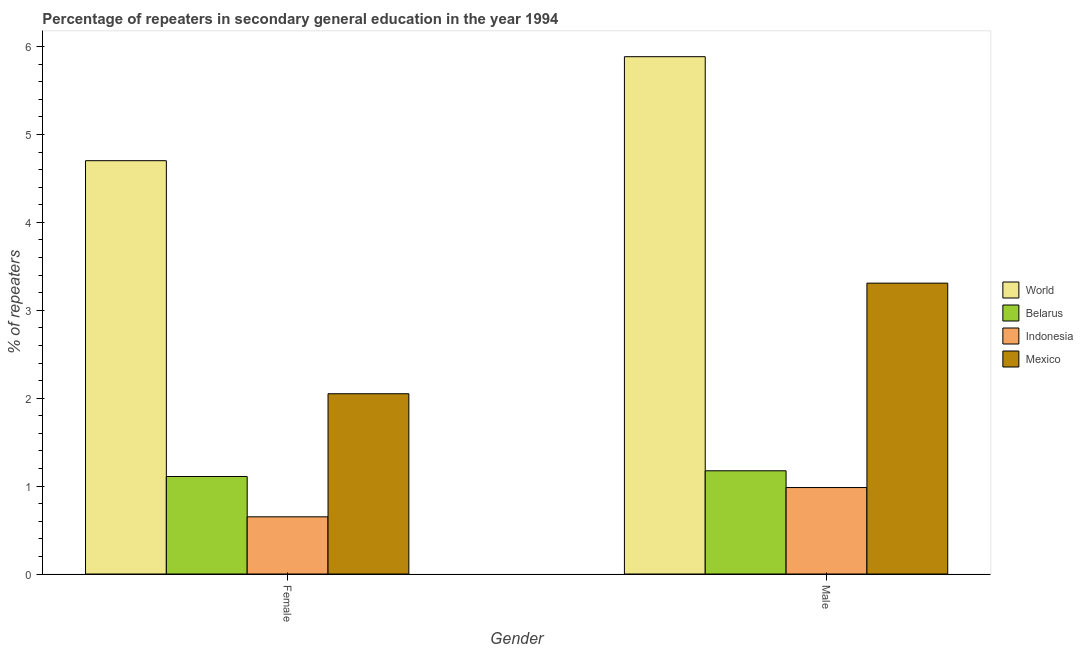How many groups of bars are there?
Give a very brief answer. 2. Are the number of bars on each tick of the X-axis equal?
Your answer should be very brief. Yes. How many bars are there on the 1st tick from the left?
Offer a terse response. 4. How many bars are there on the 1st tick from the right?
Offer a very short reply. 4. What is the percentage of female repeaters in World?
Your answer should be very brief. 4.7. Across all countries, what is the maximum percentage of male repeaters?
Provide a short and direct response. 5.89. Across all countries, what is the minimum percentage of female repeaters?
Provide a short and direct response. 0.65. What is the total percentage of male repeaters in the graph?
Provide a short and direct response. 11.35. What is the difference between the percentage of male repeaters in Mexico and that in Belarus?
Ensure brevity in your answer.  2.13. What is the difference between the percentage of male repeaters in Mexico and the percentage of female repeaters in Indonesia?
Your answer should be compact. 2.66. What is the average percentage of female repeaters per country?
Ensure brevity in your answer.  2.13. What is the difference between the percentage of female repeaters and percentage of male repeaters in World?
Your answer should be compact. -1.18. What is the ratio of the percentage of male repeaters in Belarus to that in Mexico?
Keep it short and to the point. 0.35. Is the percentage of female repeaters in Indonesia less than that in Belarus?
Your answer should be compact. Yes. What does the 2nd bar from the left in Male represents?
Give a very brief answer. Belarus. Are all the bars in the graph horizontal?
Make the answer very short. No. How many countries are there in the graph?
Your answer should be very brief. 4. Are the values on the major ticks of Y-axis written in scientific E-notation?
Give a very brief answer. No. Does the graph contain grids?
Your response must be concise. No. Where does the legend appear in the graph?
Your answer should be very brief. Center right. How many legend labels are there?
Make the answer very short. 4. What is the title of the graph?
Make the answer very short. Percentage of repeaters in secondary general education in the year 1994. Does "Netherlands" appear as one of the legend labels in the graph?
Make the answer very short. No. What is the label or title of the X-axis?
Offer a terse response. Gender. What is the label or title of the Y-axis?
Your answer should be compact. % of repeaters. What is the % of repeaters in World in Female?
Provide a short and direct response. 4.7. What is the % of repeaters in Belarus in Female?
Keep it short and to the point. 1.11. What is the % of repeaters in Indonesia in Female?
Provide a short and direct response. 0.65. What is the % of repeaters in Mexico in Female?
Your answer should be compact. 2.05. What is the % of repeaters in World in Male?
Your answer should be compact. 5.89. What is the % of repeaters in Belarus in Male?
Give a very brief answer. 1.17. What is the % of repeaters of Indonesia in Male?
Your answer should be compact. 0.98. What is the % of repeaters in Mexico in Male?
Offer a terse response. 3.31. Across all Gender, what is the maximum % of repeaters of World?
Provide a short and direct response. 5.89. Across all Gender, what is the maximum % of repeaters in Belarus?
Provide a short and direct response. 1.17. Across all Gender, what is the maximum % of repeaters of Indonesia?
Offer a terse response. 0.98. Across all Gender, what is the maximum % of repeaters of Mexico?
Provide a short and direct response. 3.31. Across all Gender, what is the minimum % of repeaters of World?
Your response must be concise. 4.7. Across all Gender, what is the minimum % of repeaters of Belarus?
Your response must be concise. 1.11. Across all Gender, what is the minimum % of repeaters of Indonesia?
Keep it short and to the point. 0.65. Across all Gender, what is the minimum % of repeaters in Mexico?
Your answer should be very brief. 2.05. What is the total % of repeaters in World in the graph?
Your response must be concise. 10.59. What is the total % of repeaters of Belarus in the graph?
Provide a succinct answer. 2.28. What is the total % of repeaters in Indonesia in the graph?
Make the answer very short. 1.63. What is the total % of repeaters of Mexico in the graph?
Provide a short and direct response. 5.36. What is the difference between the % of repeaters of World in Female and that in Male?
Provide a succinct answer. -1.18. What is the difference between the % of repeaters in Belarus in Female and that in Male?
Give a very brief answer. -0.06. What is the difference between the % of repeaters in Indonesia in Female and that in Male?
Provide a succinct answer. -0.33. What is the difference between the % of repeaters of Mexico in Female and that in Male?
Offer a very short reply. -1.26. What is the difference between the % of repeaters of World in Female and the % of repeaters of Belarus in Male?
Provide a short and direct response. 3.53. What is the difference between the % of repeaters of World in Female and the % of repeaters of Indonesia in Male?
Offer a terse response. 3.72. What is the difference between the % of repeaters in World in Female and the % of repeaters in Mexico in Male?
Give a very brief answer. 1.39. What is the difference between the % of repeaters of Belarus in Female and the % of repeaters of Indonesia in Male?
Your answer should be compact. 0.13. What is the difference between the % of repeaters of Belarus in Female and the % of repeaters of Mexico in Male?
Your answer should be very brief. -2.2. What is the difference between the % of repeaters in Indonesia in Female and the % of repeaters in Mexico in Male?
Your answer should be compact. -2.66. What is the average % of repeaters of World per Gender?
Your answer should be very brief. 5.29. What is the average % of repeaters in Belarus per Gender?
Keep it short and to the point. 1.14. What is the average % of repeaters in Indonesia per Gender?
Make the answer very short. 0.82. What is the average % of repeaters of Mexico per Gender?
Give a very brief answer. 2.68. What is the difference between the % of repeaters in World and % of repeaters in Belarus in Female?
Make the answer very short. 3.59. What is the difference between the % of repeaters of World and % of repeaters of Indonesia in Female?
Ensure brevity in your answer.  4.05. What is the difference between the % of repeaters of World and % of repeaters of Mexico in Female?
Your answer should be compact. 2.65. What is the difference between the % of repeaters in Belarus and % of repeaters in Indonesia in Female?
Offer a very short reply. 0.46. What is the difference between the % of repeaters of Belarus and % of repeaters of Mexico in Female?
Offer a terse response. -0.94. What is the difference between the % of repeaters of Indonesia and % of repeaters of Mexico in Female?
Your answer should be compact. -1.4. What is the difference between the % of repeaters of World and % of repeaters of Belarus in Male?
Ensure brevity in your answer.  4.71. What is the difference between the % of repeaters of World and % of repeaters of Indonesia in Male?
Keep it short and to the point. 4.9. What is the difference between the % of repeaters in World and % of repeaters in Mexico in Male?
Keep it short and to the point. 2.58. What is the difference between the % of repeaters in Belarus and % of repeaters in Indonesia in Male?
Provide a succinct answer. 0.19. What is the difference between the % of repeaters in Belarus and % of repeaters in Mexico in Male?
Give a very brief answer. -2.13. What is the difference between the % of repeaters of Indonesia and % of repeaters of Mexico in Male?
Give a very brief answer. -2.33. What is the ratio of the % of repeaters in World in Female to that in Male?
Offer a very short reply. 0.8. What is the ratio of the % of repeaters of Belarus in Female to that in Male?
Your response must be concise. 0.94. What is the ratio of the % of repeaters of Indonesia in Female to that in Male?
Your response must be concise. 0.66. What is the ratio of the % of repeaters of Mexico in Female to that in Male?
Make the answer very short. 0.62. What is the difference between the highest and the second highest % of repeaters in World?
Ensure brevity in your answer.  1.18. What is the difference between the highest and the second highest % of repeaters of Belarus?
Your answer should be compact. 0.06. What is the difference between the highest and the second highest % of repeaters in Indonesia?
Provide a succinct answer. 0.33. What is the difference between the highest and the second highest % of repeaters in Mexico?
Give a very brief answer. 1.26. What is the difference between the highest and the lowest % of repeaters of World?
Make the answer very short. 1.18. What is the difference between the highest and the lowest % of repeaters in Belarus?
Provide a short and direct response. 0.06. What is the difference between the highest and the lowest % of repeaters in Indonesia?
Provide a short and direct response. 0.33. What is the difference between the highest and the lowest % of repeaters of Mexico?
Offer a terse response. 1.26. 